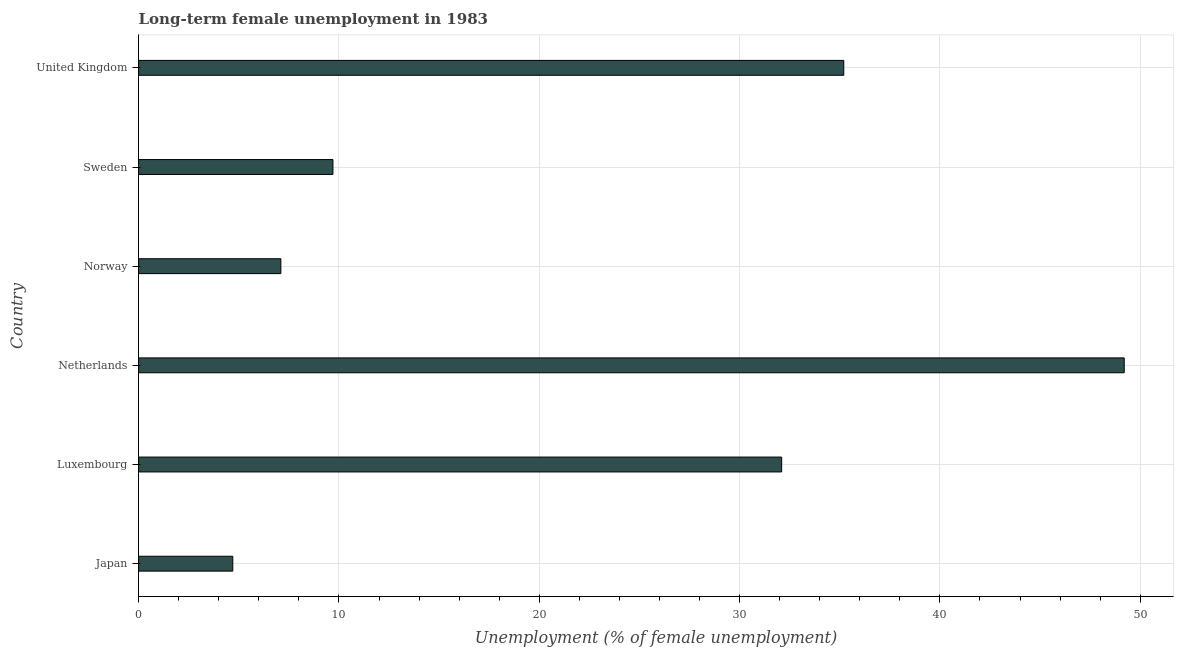Does the graph contain any zero values?
Keep it short and to the point. No. Does the graph contain grids?
Your answer should be compact. Yes. What is the title of the graph?
Give a very brief answer. Long-term female unemployment in 1983. What is the label or title of the X-axis?
Your answer should be compact. Unemployment (% of female unemployment). What is the label or title of the Y-axis?
Give a very brief answer. Country. What is the long-term female unemployment in Netherlands?
Offer a terse response. 49.2. Across all countries, what is the maximum long-term female unemployment?
Your answer should be very brief. 49.2. Across all countries, what is the minimum long-term female unemployment?
Ensure brevity in your answer.  4.7. In which country was the long-term female unemployment maximum?
Ensure brevity in your answer.  Netherlands. What is the sum of the long-term female unemployment?
Provide a succinct answer. 138. What is the difference between the long-term female unemployment in Netherlands and Norway?
Provide a succinct answer. 42.1. What is the average long-term female unemployment per country?
Provide a short and direct response. 23. What is the median long-term female unemployment?
Your answer should be very brief. 20.9. What is the ratio of the long-term female unemployment in Japan to that in United Kingdom?
Keep it short and to the point. 0.13. Is the long-term female unemployment in Luxembourg less than that in Norway?
Keep it short and to the point. No. Is the difference between the long-term female unemployment in Netherlands and Sweden greater than the difference between any two countries?
Keep it short and to the point. No. What is the difference between the highest and the second highest long-term female unemployment?
Ensure brevity in your answer.  14. What is the difference between the highest and the lowest long-term female unemployment?
Offer a very short reply. 44.5. How many countries are there in the graph?
Your answer should be very brief. 6. What is the difference between two consecutive major ticks on the X-axis?
Provide a short and direct response. 10. What is the Unemployment (% of female unemployment) in Japan?
Your answer should be very brief. 4.7. What is the Unemployment (% of female unemployment) in Luxembourg?
Offer a terse response. 32.1. What is the Unemployment (% of female unemployment) in Netherlands?
Offer a very short reply. 49.2. What is the Unemployment (% of female unemployment) of Norway?
Offer a terse response. 7.1. What is the Unemployment (% of female unemployment) of Sweden?
Offer a terse response. 9.7. What is the Unemployment (% of female unemployment) in United Kingdom?
Your answer should be very brief. 35.2. What is the difference between the Unemployment (% of female unemployment) in Japan and Luxembourg?
Offer a very short reply. -27.4. What is the difference between the Unemployment (% of female unemployment) in Japan and Netherlands?
Provide a succinct answer. -44.5. What is the difference between the Unemployment (% of female unemployment) in Japan and United Kingdom?
Ensure brevity in your answer.  -30.5. What is the difference between the Unemployment (% of female unemployment) in Luxembourg and Netherlands?
Provide a succinct answer. -17.1. What is the difference between the Unemployment (% of female unemployment) in Luxembourg and Norway?
Give a very brief answer. 25. What is the difference between the Unemployment (% of female unemployment) in Luxembourg and Sweden?
Keep it short and to the point. 22.4. What is the difference between the Unemployment (% of female unemployment) in Netherlands and Norway?
Provide a short and direct response. 42.1. What is the difference between the Unemployment (% of female unemployment) in Netherlands and Sweden?
Make the answer very short. 39.5. What is the difference between the Unemployment (% of female unemployment) in Norway and United Kingdom?
Give a very brief answer. -28.1. What is the difference between the Unemployment (% of female unemployment) in Sweden and United Kingdom?
Provide a succinct answer. -25.5. What is the ratio of the Unemployment (% of female unemployment) in Japan to that in Luxembourg?
Make the answer very short. 0.15. What is the ratio of the Unemployment (% of female unemployment) in Japan to that in Netherlands?
Make the answer very short. 0.1. What is the ratio of the Unemployment (% of female unemployment) in Japan to that in Norway?
Provide a short and direct response. 0.66. What is the ratio of the Unemployment (% of female unemployment) in Japan to that in Sweden?
Your answer should be compact. 0.48. What is the ratio of the Unemployment (% of female unemployment) in Japan to that in United Kingdom?
Make the answer very short. 0.13. What is the ratio of the Unemployment (% of female unemployment) in Luxembourg to that in Netherlands?
Offer a terse response. 0.65. What is the ratio of the Unemployment (% of female unemployment) in Luxembourg to that in Norway?
Your answer should be very brief. 4.52. What is the ratio of the Unemployment (% of female unemployment) in Luxembourg to that in Sweden?
Ensure brevity in your answer.  3.31. What is the ratio of the Unemployment (% of female unemployment) in Luxembourg to that in United Kingdom?
Make the answer very short. 0.91. What is the ratio of the Unemployment (% of female unemployment) in Netherlands to that in Norway?
Make the answer very short. 6.93. What is the ratio of the Unemployment (% of female unemployment) in Netherlands to that in Sweden?
Give a very brief answer. 5.07. What is the ratio of the Unemployment (% of female unemployment) in Netherlands to that in United Kingdom?
Your answer should be very brief. 1.4. What is the ratio of the Unemployment (% of female unemployment) in Norway to that in Sweden?
Keep it short and to the point. 0.73. What is the ratio of the Unemployment (% of female unemployment) in Norway to that in United Kingdom?
Offer a very short reply. 0.2. What is the ratio of the Unemployment (% of female unemployment) in Sweden to that in United Kingdom?
Make the answer very short. 0.28. 